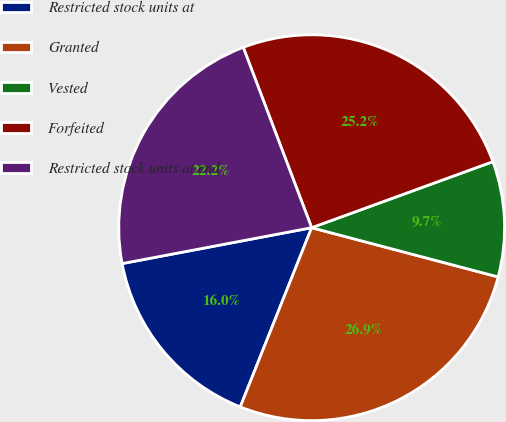Convert chart. <chart><loc_0><loc_0><loc_500><loc_500><pie_chart><fcel>Restricted stock units at<fcel>Granted<fcel>Vested<fcel>Forfeited<fcel>Restricted stock units at end<nl><fcel>15.99%<fcel>26.93%<fcel>9.67%<fcel>25.21%<fcel>22.21%<nl></chart> 